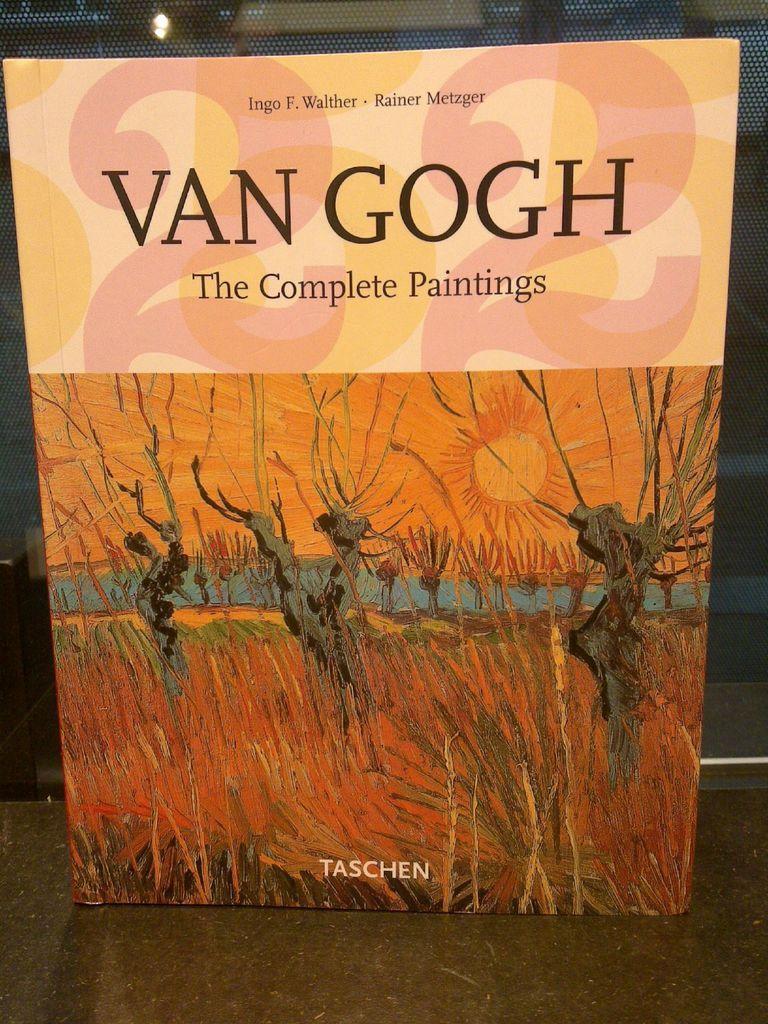Who is the book about?
Your answer should be compact. Van gogh. 